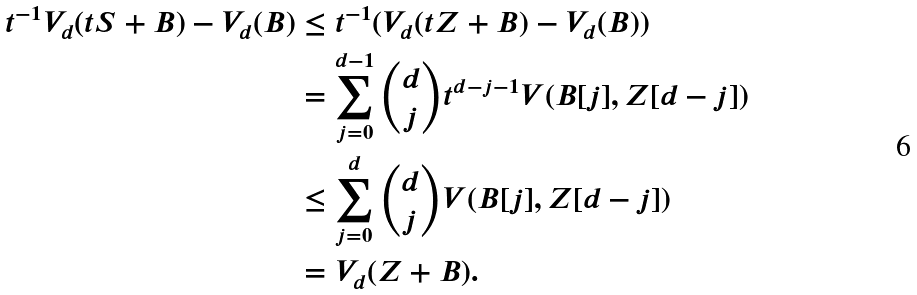Convert formula to latex. <formula><loc_0><loc_0><loc_500><loc_500>t ^ { - 1 } V _ { d } ( t S + B ) - V _ { d } ( B ) & \leq t ^ { - 1 } ( V _ { d } ( t Z + B ) - V _ { d } ( B ) ) \\ & = \sum _ { j = 0 } ^ { d - 1 } \binom { d } { j } t ^ { d - j - 1 } V ( B [ j ] , Z [ d - j ] ) \\ & \leq \sum _ { j = 0 } ^ { d } \binom { d } { j } V ( B [ j ] , Z [ d - j ] ) \\ & = V _ { d } ( Z + B ) .</formula> 